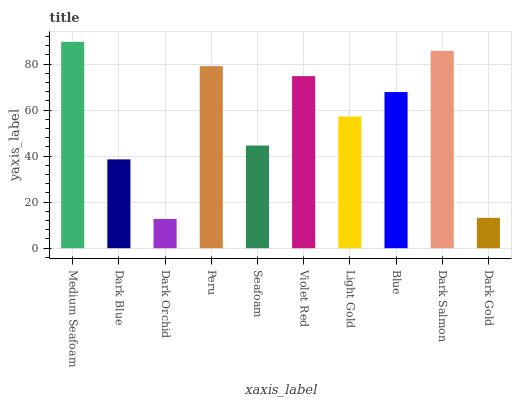Is Dark Orchid the minimum?
Answer yes or no. Yes. Is Medium Seafoam the maximum?
Answer yes or no. Yes. Is Dark Blue the minimum?
Answer yes or no. No. Is Dark Blue the maximum?
Answer yes or no. No. Is Medium Seafoam greater than Dark Blue?
Answer yes or no. Yes. Is Dark Blue less than Medium Seafoam?
Answer yes or no. Yes. Is Dark Blue greater than Medium Seafoam?
Answer yes or no. No. Is Medium Seafoam less than Dark Blue?
Answer yes or no. No. Is Blue the high median?
Answer yes or no. Yes. Is Light Gold the low median?
Answer yes or no. Yes. Is Dark Gold the high median?
Answer yes or no. No. Is Seafoam the low median?
Answer yes or no. No. 